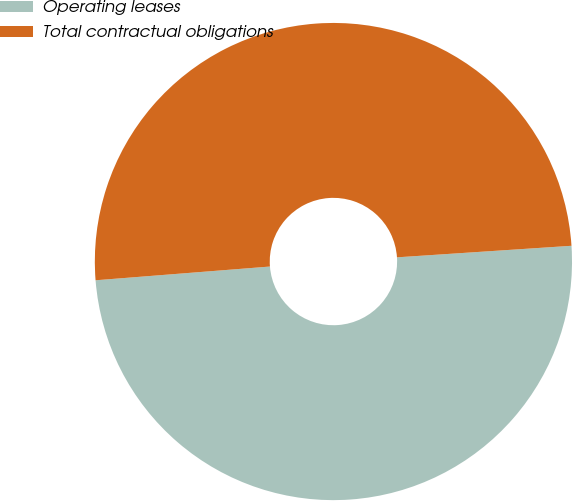<chart> <loc_0><loc_0><loc_500><loc_500><pie_chart><fcel>Operating leases<fcel>Total contractual obligations<nl><fcel>49.8%<fcel>50.2%<nl></chart> 